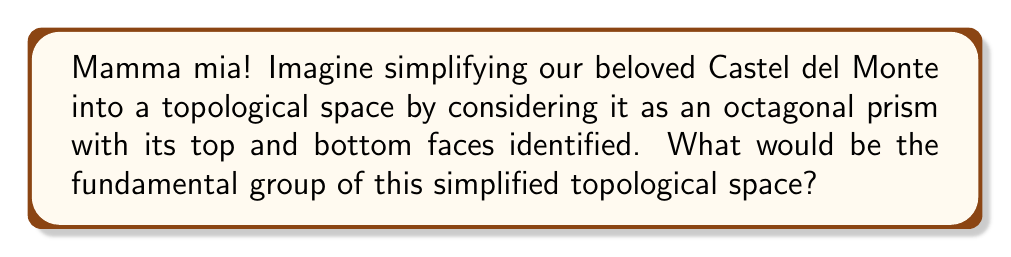Can you answer this question? Let's approach this step-by-step, amici!

1) First, let's visualize our simplified Castel del Monte. It's an octagonal prism with the top and bottom faces identified. This is topologically equivalent to a solid torus with an octagonal cross-section.

2) Now, we know that the fundamental group of a space doesn't depend on its fine details, but rather on its overall structure. The octagonal cross-section doesn't affect the fundamental group - it's the same as for a regular torus.

3) The fundamental group of a torus is well-known in topology. It's the free abelian group on two generators, often denoted as $\mathbb{Z} \times \mathbb{Z}$.

4) To understand why, let's think about the possible loops on our simplified castle:
   - We can go around the castle horizontally (like walking around the castle's walls).
   - We can go vertically from bottom to top (which is the same as top to bottom since they're identified).
   - Any other loop can be decomposed into combinations of these two basic loops.

5) These two types of loops correspond to the two generators of the fundamental group. We can go around each loop multiple times in either direction, which is why each generator is like the integers $\mathbb{Z}$.

6) The loops commute with each other - it doesn't matter which order we do them in. This is why the group is abelian.

7) Mathematically, we can write elements of this group as pairs $(a,b)$ where $a$ and $b$ are integers. $a$ represents how many times we go around horizontally, and $b$ represents how many times we go around vertically.

Therefore, the fundamental group of our simplified Castel del Monte is isomorphic to $\mathbb{Z} \times \mathbb{Z}$.
Answer: The fundamental group is $\pi_1(X) \cong \mathbb{Z} \times \mathbb{Z}$, where $X$ is our simplified Castel del Monte topological space. 